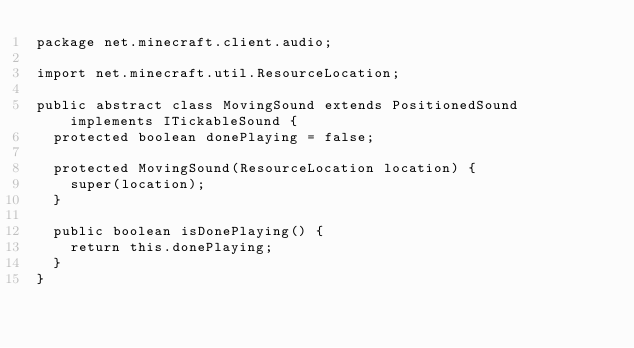<code> <loc_0><loc_0><loc_500><loc_500><_Java_>package net.minecraft.client.audio;

import net.minecraft.util.ResourceLocation;

public abstract class MovingSound extends PositionedSound implements ITickableSound {
	protected boolean donePlaying = false;

	protected MovingSound(ResourceLocation location) {
		super(location);
	}

	public boolean isDonePlaying() {
		return this.donePlaying;
	}
}
</code> 